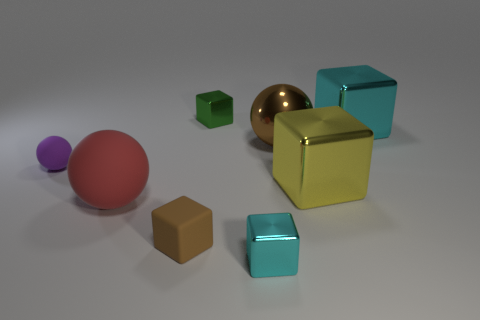Subtract all big red rubber spheres. How many spheres are left? 2 Subtract all green cylinders. How many cyan cubes are left? 2 Subtract all brown blocks. How many blocks are left? 4 Subtract 1 balls. How many balls are left? 2 Subtract all blue cubes. Subtract all purple balls. How many cubes are left? 5 Add 1 yellow shiny things. How many objects exist? 9 Subtract all balls. How many objects are left? 5 Add 3 small cyan metallic objects. How many small cyan metallic objects exist? 4 Subtract 1 brown blocks. How many objects are left? 7 Subtract all big gray cylinders. Subtract all large matte objects. How many objects are left? 7 